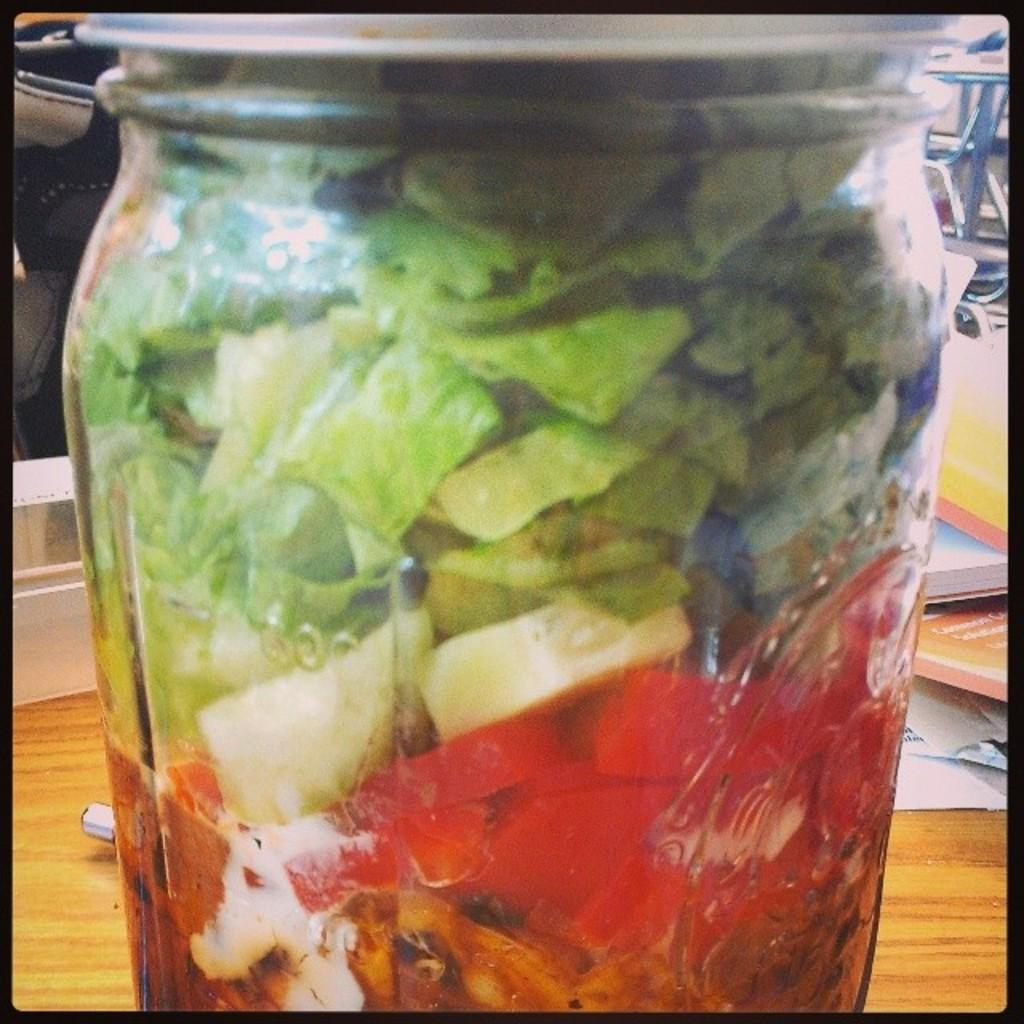What is inside the jar that is visible in the image? There is a jar with vegetables in the image. Where is the jar located in the image? The jar is placed on a table. What else can be seen on the table in the image? There are books and papers on the table. What is present on the floor in the image? There is an object on the floor in the image. What historical event is being discussed in the image? There is no indication of a historical event being discussed in the image; it primarily features a jar with vegetables, books, papers, and an object on the floor. 